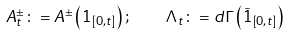Convert formula to latex. <formula><loc_0><loc_0><loc_500><loc_500>A _ { t } ^ { \pm } \colon = A ^ { \pm } \left ( 1 _ { \left [ 0 , t \right ] } \right ) ; \quad \Lambda _ { t } \colon = d \Gamma \left ( \tilde { 1 } _ { \left [ 0 , t \right ] } \right )</formula> 